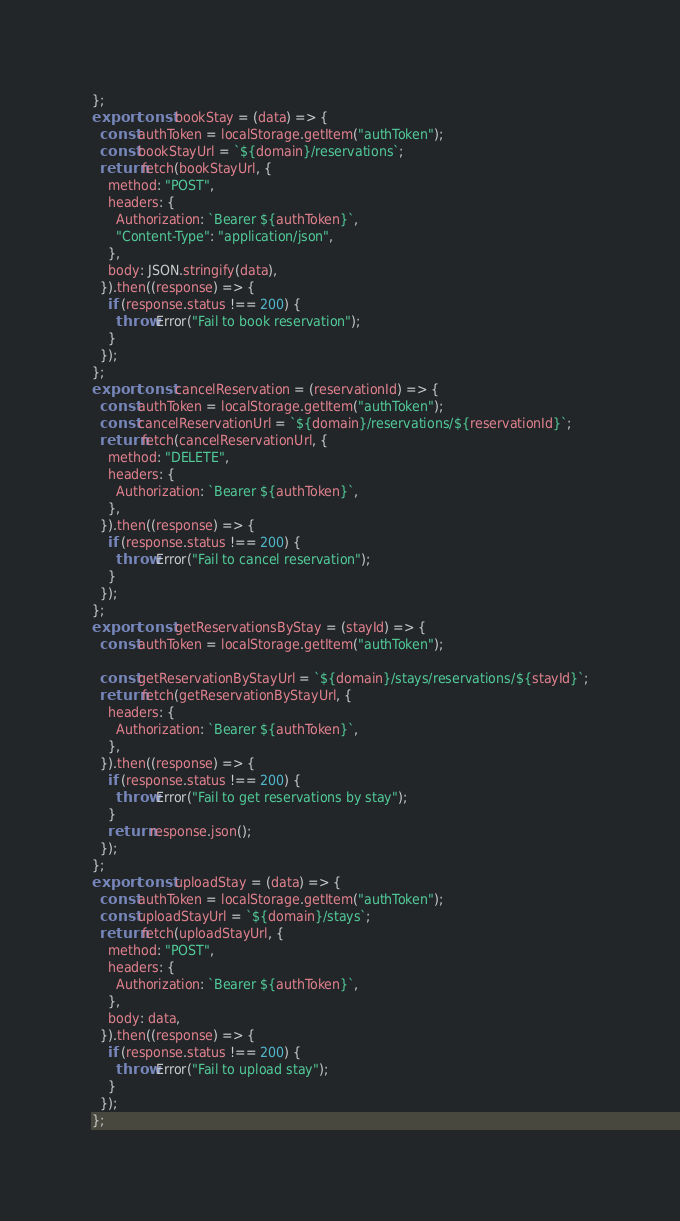Convert code to text. <code><loc_0><loc_0><loc_500><loc_500><_JavaScript_>};
export const bookStay = (data) => {
  const authToken = localStorage.getItem("authToken");
  const bookStayUrl = `${domain}/reservations`;
  return fetch(bookStayUrl, {
    method: "POST",
    headers: {
      Authorization: `Bearer ${authToken}`,
      "Content-Type": "application/json",
    },
    body: JSON.stringify(data),
  }).then((response) => {
    if (response.status !== 200) {
      throw Error("Fail to book reservation");
    }
  });
};
export const cancelReservation = (reservationId) => {
  const authToken = localStorage.getItem("authToken");
  const cancelReservationUrl = `${domain}/reservations/${reservationId}`;
  return fetch(cancelReservationUrl, {
    method: "DELETE",
    headers: {
      Authorization: `Bearer ${authToken}`,
    },
  }).then((response) => {
    if (response.status !== 200) {
      throw Error("Fail to cancel reservation");
    }
  });
};
export const getReservationsByStay = (stayId) => {
  const authToken = localStorage.getItem("authToken");

  const getReservationByStayUrl = `${domain}/stays/reservations/${stayId}`;
  return fetch(getReservationByStayUrl, {
    headers: {
      Authorization: `Bearer ${authToken}`,
    },
  }).then((response) => {
    if (response.status !== 200) {
      throw Error("Fail to get reservations by stay");
    }
    return response.json();
  });
};
export const uploadStay = (data) => {
  const authToken = localStorage.getItem("authToken");
  const uploadStayUrl = `${domain}/stays`;
  return fetch(uploadStayUrl, {
    method: "POST",
    headers: {
      Authorization: `Bearer ${authToken}`,
    },
    body: data,
  }).then((response) => {
    if (response.status !== 200) {
      throw Error("Fail to upload stay");
    }
  });
};
</code> 